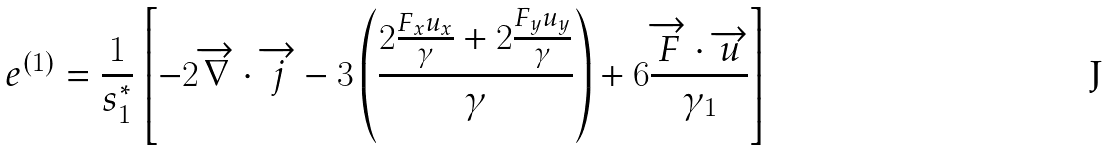<formula> <loc_0><loc_0><loc_500><loc_500>e ^ { ( 1 ) } = \frac { 1 } { s _ { 1 } ^ { * } } \left [ - 2 \overrightarrow { \nabla } \cdot \overrightarrow { j } - 3 \left ( \frac { 2 \frac { F _ { x } u _ { x } } { \gamma } + 2 \frac { F _ { y } u _ { y } } { \gamma } } { \gamma } \right ) + 6 \frac { \overrightarrow { F } \cdot \overrightarrow { u } } { \gamma _ { 1 } } \right ]</formula> 